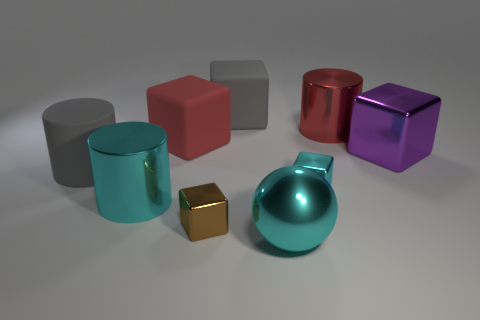The red cube is what size?
Provide a short and direct response. Large. There is a large ball; is its color the same as the big metallic cylinder that is in front of the red metallic object?
Provide a succinct answer. Yes. There is a thing that is behind the red thing that is behind the red matte object; what is its color?
Make the answer very short. Gray. Is the shape of the gray object that is in front of the large metal cube the same as  the red metallic object?
Provide a succinct answer. Yes. How many cyan objects are both to the right of the small brown shiny thing and to the left of the cyan metal sphere?
Offer a terse response. 0. The metallic cylinder that is to the right of the big gray thing that is behind the red object that is to the left of the cyan shiny ball is what color?
Give a very brief answer. Red. What number of tiny cyan metallic objects are right of the gray object that is behind the big red metallic thing?
Provide a short and direct response. 1. What number of other things are there of the same shape as the tiny cyan shiny object?
Your response must be concise. 4. How many objects are either small objects or cylinders left of the metal ball?
Ensure brevity in your answer.  4. Is the number of tiny metal cubes that are behind the big red shiny cylinder greater than the number of small cyan shiny cubes that are in front of the cyan cylinder?
Offer a very short reply. No. 